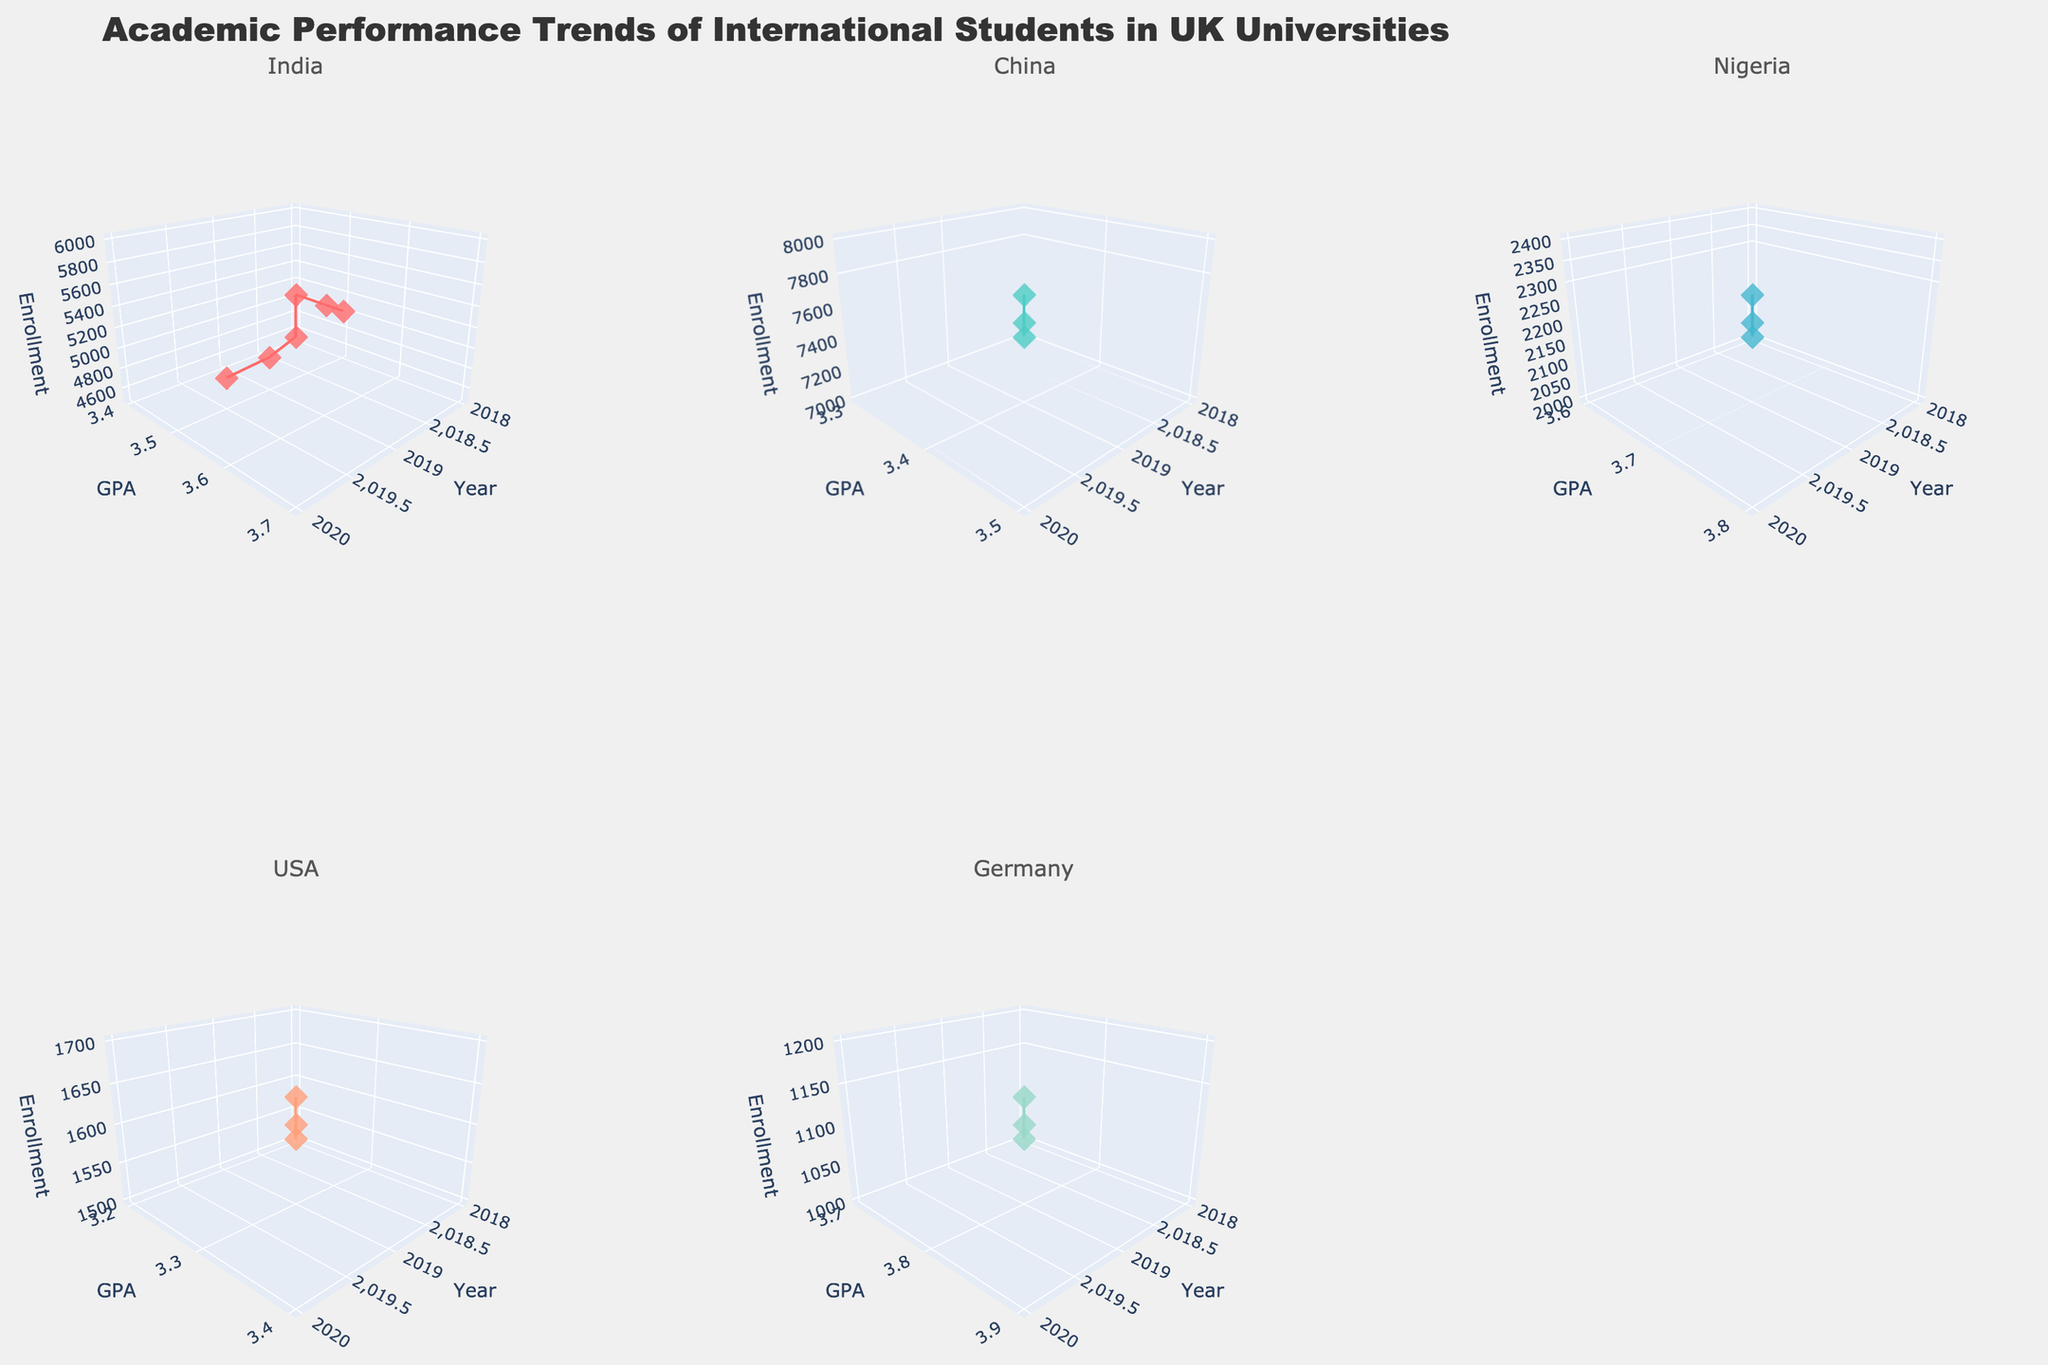What's the main title of the figure? The main title of the figure can be found at the top of the plot. In this case, it is "Academic Performance Trends of International Students in UK Universities."
Answer: Academic Performance Trends of International Students in UK Universities How is the GPA for Computer Science students from India trending over the years? By observing the subplot for India, we see the GPA values for Computer Science students increasing from 2018 to 2020: 3.5, 3.6, 3.7 respectively.
Answer: Increasing What is the field of study for Nigerian students in the plot? According to the hover text on the subplot for Nigeria, all the data points are labeled with the field "Medicine."
Answer: Medicine How many data points are there for each subplot? Each subplot contains three data points, one for each year from 2018 to 2020. This is consistent across all subplots.
Answer: 3 Which country shows the highest GPA in 2020? Looking at the 2020 data points on each subplot, Germany's Physics students have the highest GPA of 3.9.
Answer: Germany How does the enrollment for Business students from China change from 2018 to 2020? By examining the subplot for China, the enrollment increases from 7000 in 2018 to 8000 in 2020, with intermediate values of 7500 in 2019.
Answer: Increasing Compare the trends of GPA for Engineering students from India and Law students from the USA between 2018 and 2020. India's Engineering GPA increases from 3.4 to 3.6, while USA's Law GPA increases from 3.2 to 3.4. Both show an increasing trend, but India's GPA starts higher and increases more in absolute terms.
Answer: Both increasing Which field of study has the lowest initial GPA in 2018 and which country does it belong to? By comparing the GPA values in each subplot for 2018, the field of study with the lowest GPA is Law from the USA at 3.2.
Answer: Law (USA) What is the average enrollment of Computer Science students from India over the 3 years? The enrollments for Computer Science students from India for 2018, 2019, and 2020 are 5000, 5500, and 6000 respectively. The average is calculated as (5000+5500+6000)/3 = 16500/3 = 5500.
Answer: 5500 Which country has the smallest increase in enrollment from 2018 to 2020? By observing each country's enrollment trend from 2018 to 2020, the USA’s Law field has the smallest increase, from 1500 to 1700, a change of 200.
Answer: USA 